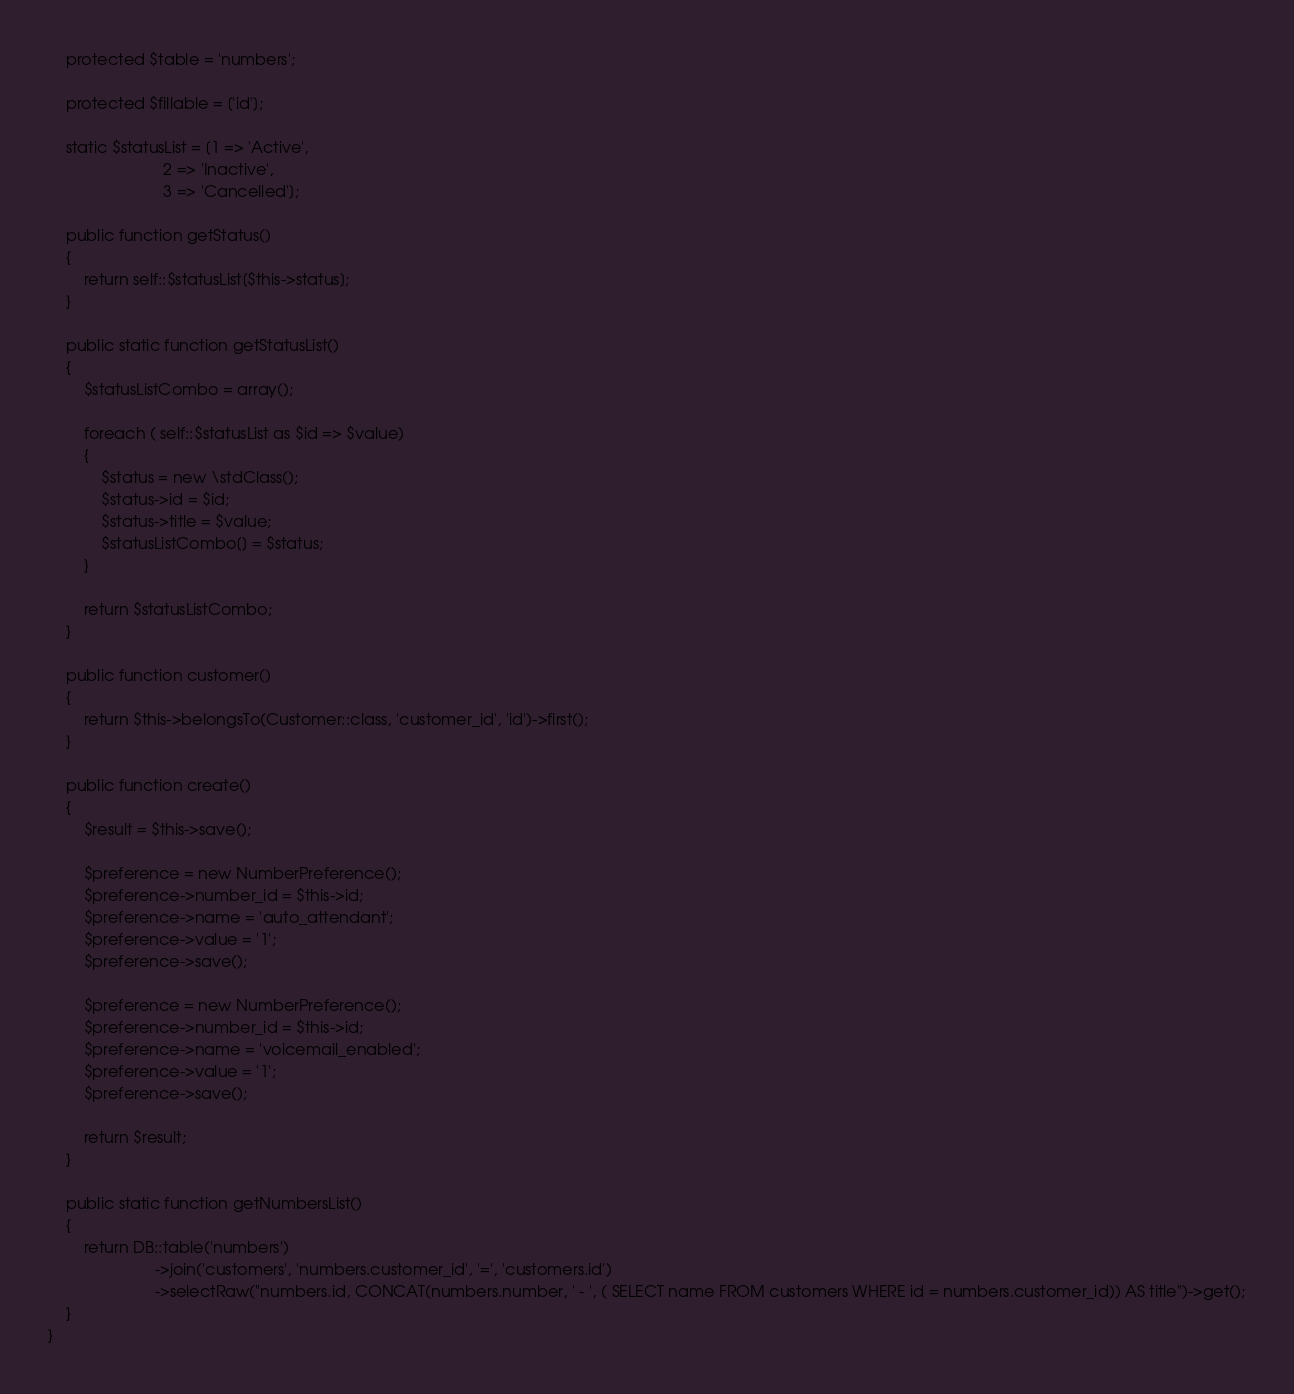Convert code to text. <code><loc_0><loc_0><loc_500><loc_500><_PHP_>
    protected $table = 'numbers';

    protected $fillable = ['id'];

    static $statusList = [1 => 'Active',
                          2 => 'Inactive',
                          3 => 'Cancelled'];

    public function getStatus()
    {
        return self::$statusList[$this->status];
    }

    public static function getStatusList()
    {
        $statusListCombo = array();

        foreach ( self::$statusList as $id => $value)
        {
            $status = new \stdClass();
            $status->id = $id;
            $status->title = $value;
            $statusListCombo[] = $status;
        }

        return $statusListCombo;
    }

    public function customer()
    {
        return $this->belongsTo(Customer::class, 'customer_id', 'id')->first();
    }

    public function create()
    {
        $result = $this->save();

        $preference = new NumberPreference();
        $preference->number_id = $this->id;
        $preference->name = 'auto_attendant';
        $preference->value = '1';
        $preference->save();

        $preference = new NumberPreference();
        $preference->number_id = $this->id;
        $preference->name = 'voicemail_enabled';
        $preference->value = '1';
        $preference->save();

        return $result;
    }

    public static function getNumbersList()
    {
        return DB::table('numbers')
                        ->join('customers', 'numbers.customer_id', '=', 'customers.id')
                        ->selectRaw("numbers.id, CONCAT(numbers.number, ' - ', ( SELECT name FROM customers WHERE id = numbers.customer_id)) AS title")->get();
    }
}
</code> 